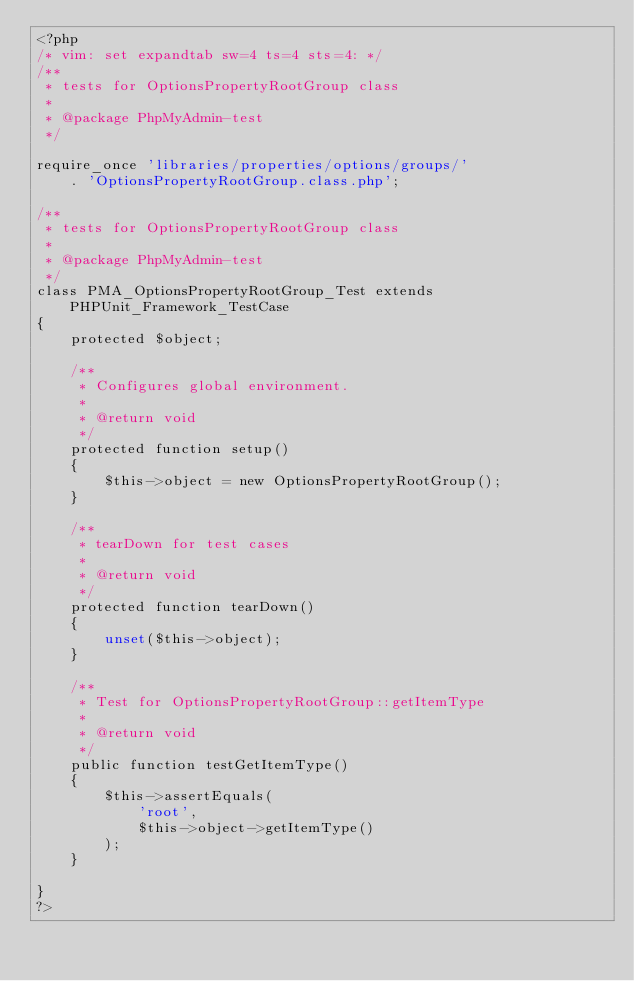Convert code to text. <code><loc_0><loc_0><loc_500><loc_500><_PHP_><?php
/* vim: set expandtab sw=4 ts=4 sts=4: */
/**
 * tests for OptionsPropertyRootGroup class
 *
 * @package PhpMyAdmin-test
 */

require_once 'libraries/properties/options/groups/'
    . 'OptionsPropertyRootGroup.class.php';

/**
 * tests for OptionsPropertyRootGroup class
 *
 * @package PhpMyAdmin-test
 */
class PMA_OptionsPropertyRootGroup_Test extends PHPUnit_Framework_TestCase
{
    protected $object;

    /**
     * Configures global environment.
     *
     * @return void
     */
    protected function setup()
    {
        $this->object = new OptionsPropertyRootGroup();
    }

    /**
     * tearDown for test cases
     *
     * @return void
     */
    protected function tearDown()
    {
        unset($this->object);
    }

    /**
     * Test for OptionsPropertyRootGroup::getItemType
     *
     * @return void
     */
    public function testGetItemType()
    {
        $this->assertEquals(
            'root',
            $this->object->getItemType()
        );
    }

}
?>
</code> 